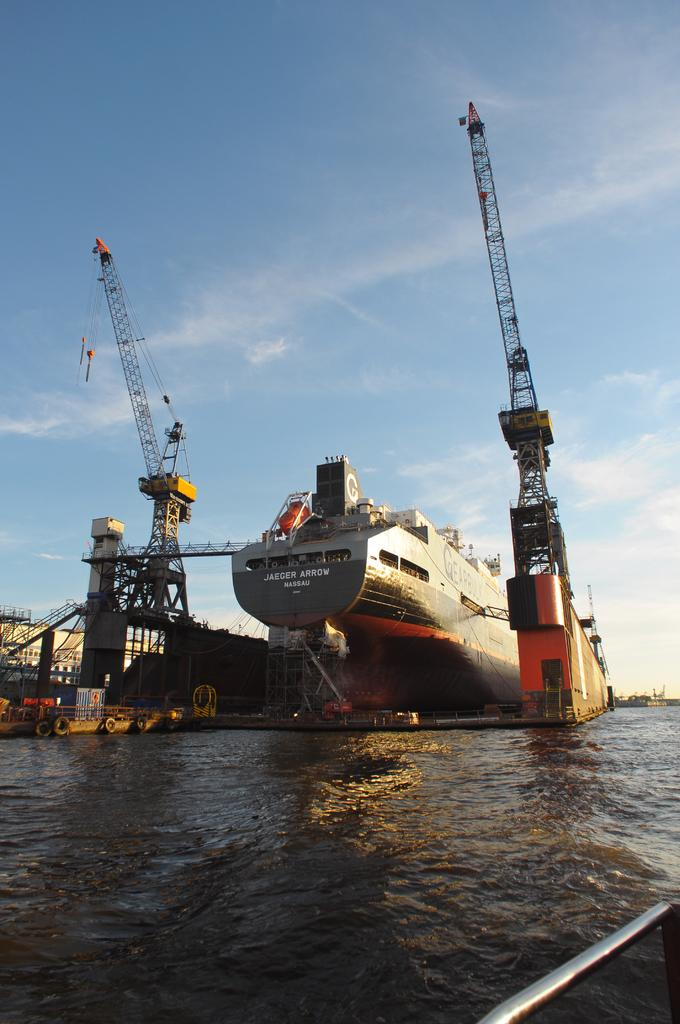What is the main subject in the center of the image? There is a ship in the center of the image. What structures can be seen in the image? There are cranes in the image. What type of environment is depicted in the image? There is water in the front of the image, suggesting a maritime setting. What is the weather like in the image? The sky is cloudy in the image. What type of fruit is hanging from the cranes in the image? There is no fruit present in the image; the cranes are likely used for lifting and moving cargo. 